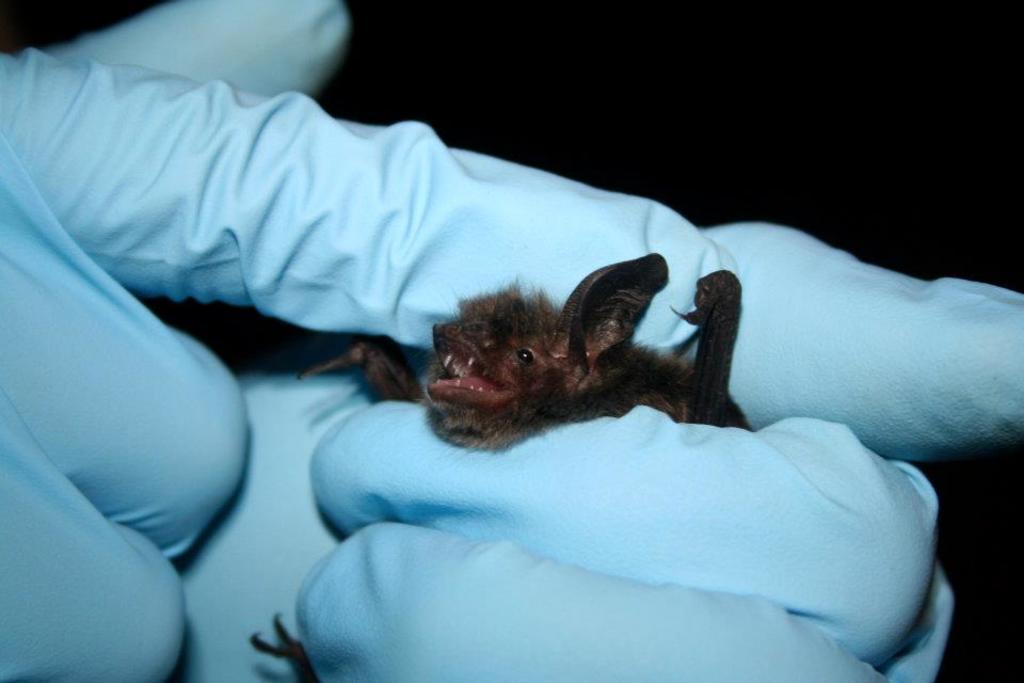How would you summarize this image in a sentence or two? In the center of this picture we can see the hands of a person wearing gloves and holding an animal and we can see some other items. The background of the image is very dark. 